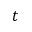Convert formula to latex. <formula><loc_0><loc_0><loc_500><loc_500>t</formula> 